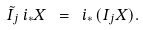<formula> <loc_0><loc_0><loc_500><loc_500>\tilde { I } _ { j } \, i _ { * } X \ = \ i _ { * } \, ( I _ { j } X ) .</formula> 